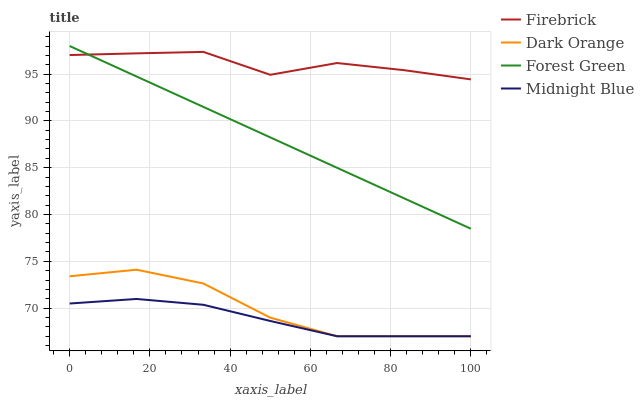Does Midnight Blue have the minimum area under the curve?
Answer yes or no. Yes. Does Firebrick have the maximum area under the curve?
Answer yes or no. Yes. Does Forest Green have the minimum area under the curve?
Answer yes or no. No. Does Forest Green have the maximum area under the curve?
Answer yes or no. No. Is Forest Green the smoothest?
Answer yes or no. Yes. Is Firebrick the roughest?
Answer yes or no. Yes. Is Firebrick the smoothest?
Answer yes or no. No. Is Forest Green the roughest?
Answer yes or no. No. Does Forest Green have the lowest value?
Answer yes or no. No. Does Firebrick have the highest value?
Answer yes or no. No. Is Midnight Blue less than Forest Green?
Answer yes or no. Yes. Is Forest Green greater than Midnight Blue?
Answer yes or no. Yes. Does Midnight Blue intersect Forest Green?
Answer yes or no. No. 